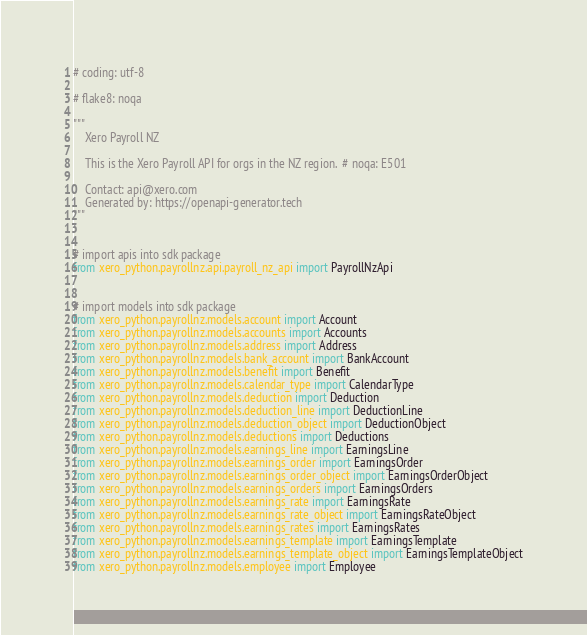Convert code to text. <code><loc_0><loc_0><loc_500><loc_500><_Python_># coding: utf-8

# flake8: noqa

"""
    Xero Payroll NZ

    This is the Xero Payroll API for orgs in the NZ region.  # noqa: E501

    Contact: api@xero.com
    Generated by: https://openapi-generator.tech
"""


# import apis into sdk package
from xero_python.payrollnz.api.payroll_nz_api import PayrollNzApi


# import models into sdk package
from xero_python.payrollnz.models.account import Account
from xero_python.payrollnz.models.accounts import Accounts
from xero_python.payrollnz.models.address import Address
from xero_python.payrollnz.models.bank_account import BankAccount
from xero_python.payrollnz.models.benefit import Benefit
from xero_python.payrollnz.models.calendar_type import CalendarType
from xero_python.payrollnz.models.deduction import Deduction
from xero_python.payrollnz.models.deduction_line import DeductionLine
from xero_python.payrollnz.models.deduction_object import DeductionObject
from xero_python.payrollnz.models.deductions import Deductions
from xero_python.payrollnz.models.earnings_line import EarningsLine
from xero_python.payrollnz.models.earnings_order import EarningsOrder
from xero_python.payrollnz.models.earnings_order_object import EarningsOrderObject
from xero_python.payrollnz.models.earnings_orders import EarningsOrders
from xero_python.payrollnz.models.earnings_rate import EarningsRate
from xero_python.payrollnz.models.earnings_rate_object import EarningsRateObject
from xero_python.payrollnz.models.earnings_rates import EarningsRates
from xero_python.payrollnz.models.earnings_template import EarningsTemplate
from xero_python.payrollnz.models.earnings_template_object import EarningsTemplateObject
from xero_python.payrollnz.models.employee import Employee</code> 